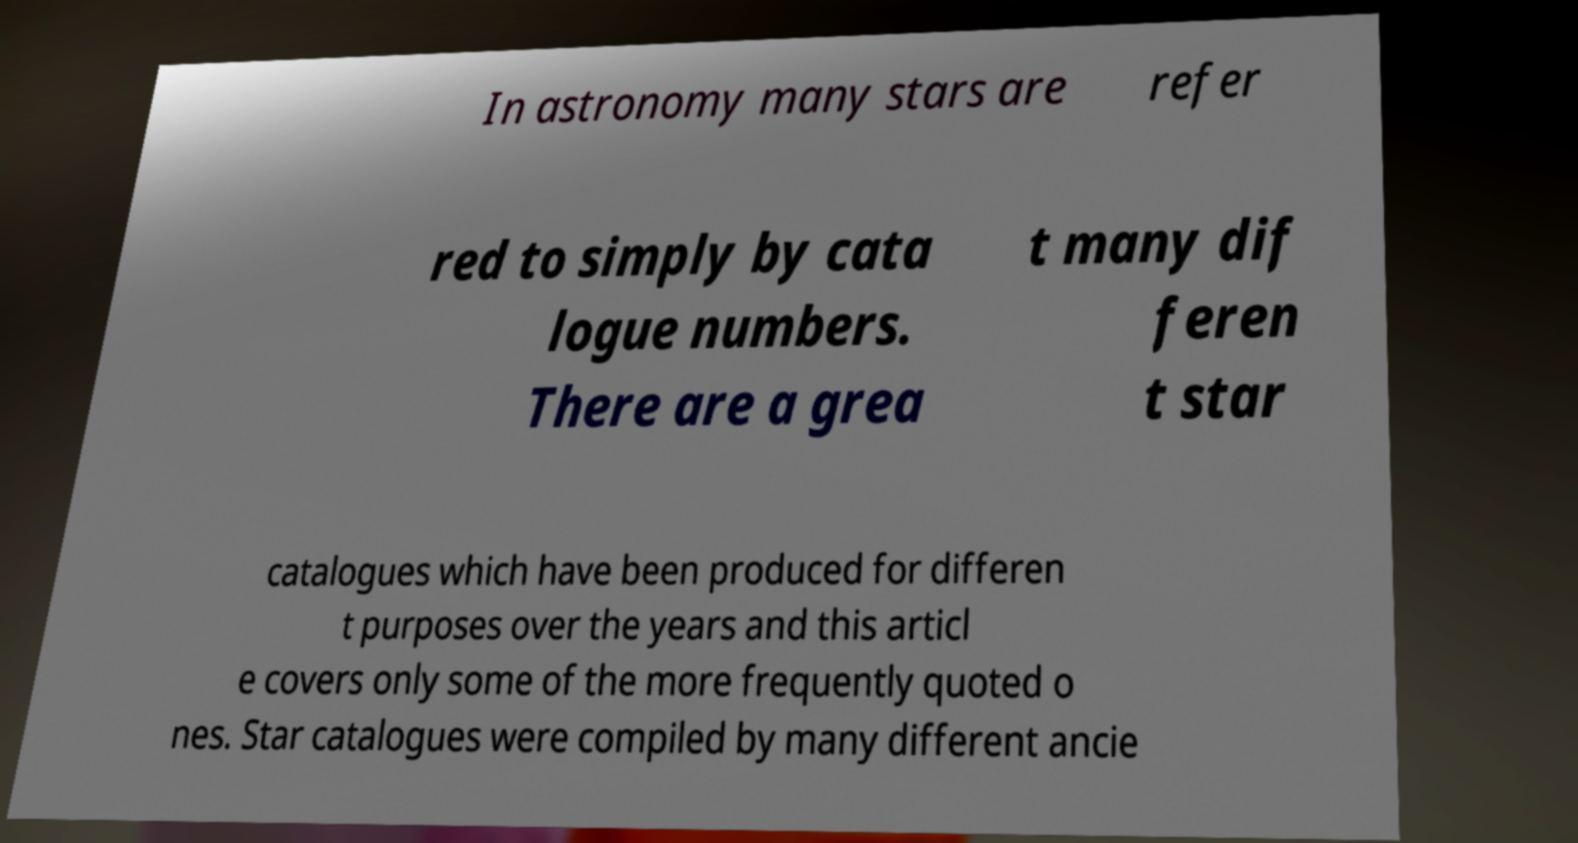There's text embedded in this image that I need extracted. Can you transcribe it verbatim? In astronomy many stars are refer red to simply by cata logue numbers. There are a grea t many dif feren t star catalogues which have been produced for differen t purposes over the years and this articl e covers only some of the more frequently quoted o nes. Star catalogues were compiled by many different ancie 